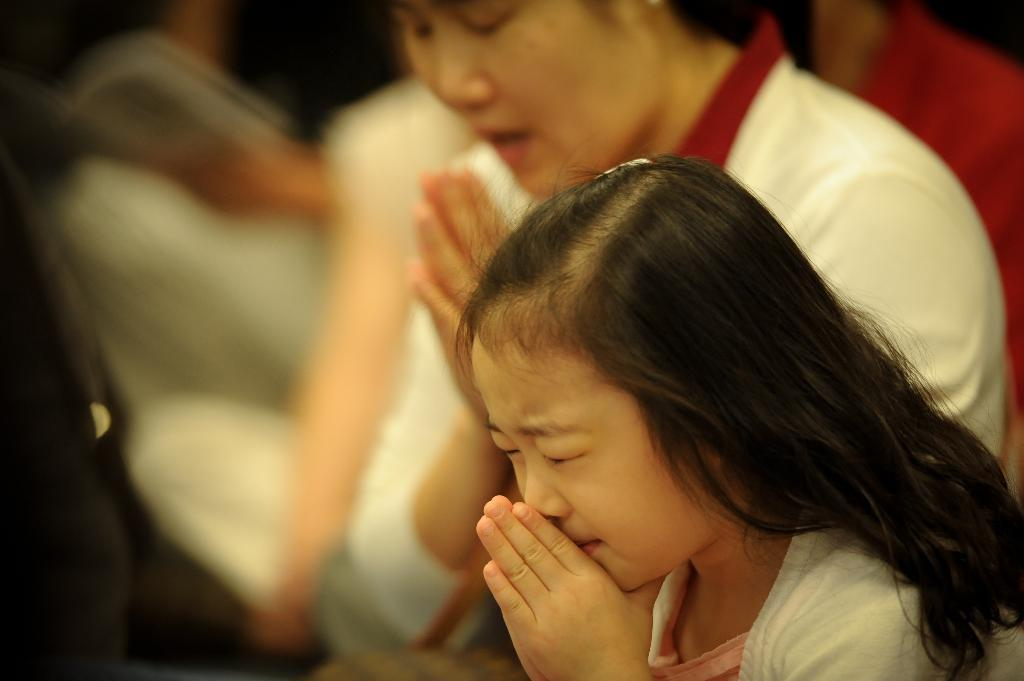What is happening in the image involving a group of people? There is a crowd in the image, and they are performing a prayer. Can you describe the setting where the crowd is located? The image may have been taken in a church, as it is a common location for prayer gatherings. What type of salt is being used by the crowd during the prayer in the image? There is no salt present in the image, as the crowd is performing a prayer and not engaging in any activity related to salt. 